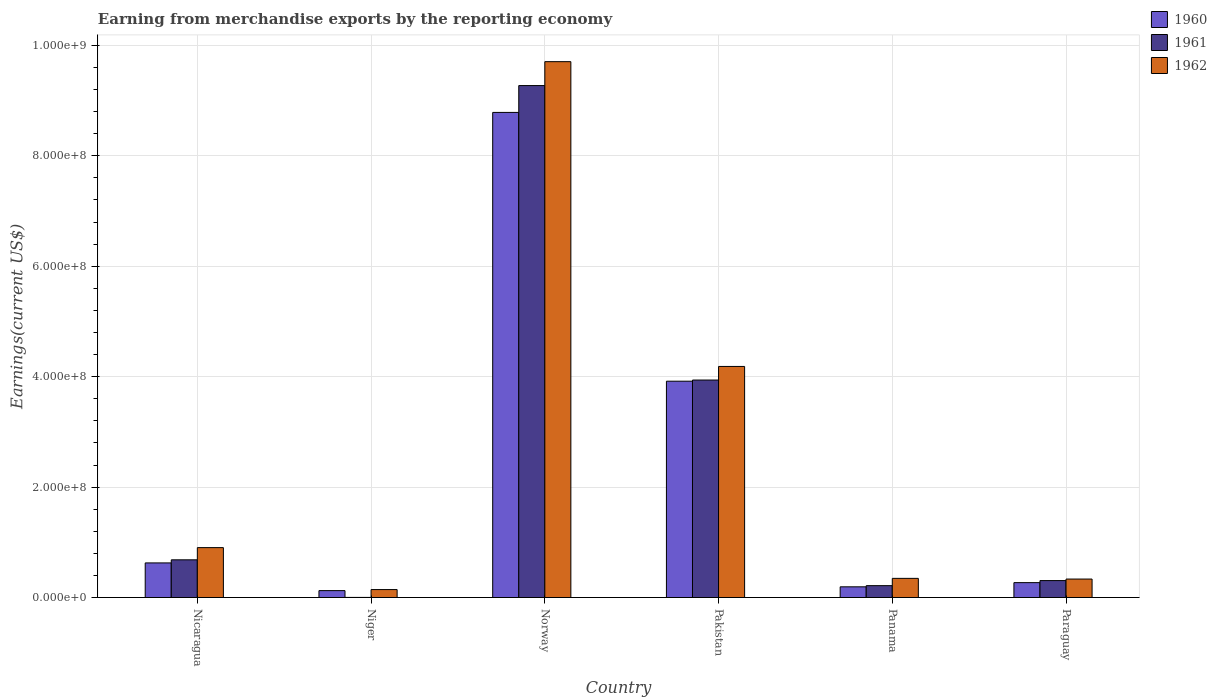How many groups of bars are there?
Keep it short and to the point. 6. Are the number of bars per tick equal to the number of legend labels?
Offer a very short reply. Yes. How many bars are there on the 5th tick from the left?
Make the answer very short. 3. How many bars are there on the 6th tick from the right?
Provide a succinct answer. 3. What is the label of the 6th group of bars from the left?
Your response must be concise. Paraguay. In how many cases, is the number of bars for a given country not equal to the number of legend labels?
Your answer should be very brief. 0. What is the amount earned from merchandise exports in 1962 in Norway?
Your answer should be compact. 9.70e+08. Across all countries, what is the maximum amount earned from merchandise exports in 1961?
Ensure brevity in your answer.  9.27e+08. Across all countries, what is the minimum amount earned from merchandise exports in 1960?
Offer a very short reply. 1.25e+07. In which country was the amount earned from merchandise exports in 1960 maximum?
Make the answer very short. Norway. In which country was the amount earned from merchandise exports in 1960 minimum?
Offer a very short reply. Niger. What is the total amount earned from merchandise exports in 1961 in the graph?
Keep it short and to the point. 1.44e+09. What is the difference between the amount earned from merchandise exports in 1960 in Nicaragua and that in Norway?
Make the answer very short. -8.16e+08. What is the difference between the amount earned from merchandise exports in 1961 in Nicaragua and the amount earned from merchandise exports in 1960 in Paraguay?
Your answer should be compact. 4.13e+07. What is the average amount earned from merchandise exports in 1961 per country?
Ensure brevity in your answer.  2.40e+08. What is the difference between the amount earned from merchandise exports of/in 1962 and amount earned from merchandise exports of/in 1961 in Norway?
Ensure brevity in your answer.  4.33e+07. In how many countries, is the amount earned from merchandise exports in 1960 greater than 880000000 US$?
Provide a short and direct response. 0. What is the ratio of the amount earned from merchandise exports in 1960 in Nicaragua to that in Niger?
Offer a very short reply. 5.02. Is the amount earned from merchandise exports in 1960 in Pakistan less than that in Panama?
Provide a short and direct response. No. Is the difference between the amount earned from merchandise exports in 1962 in Pakistan and Paraguay greater than the difference between the amount earned from merchandise exports in 1961 in Pakistan and Paraguay?
Your answer should be very brief. Yes. What is the difference between the highest and the second highest amount earned from merchandise exports in 1962?
Ensure brevity in your answer.  8.80e+08. What is the difference between the highest and the lowest amount earned from merchandise exports in 1962?
Your answer should be very brief. 9.56e+08. What does the 1st bar from the right in Niger represents?
Ensure brevity in your answer.  1962. Are all the bars in the graph horizontal?
Offer a very short reply. No. How many countries are there in the graph?
Keep it short and to the point. 6. Are the values on the major ticks of Y-axis written in scientific E-notation?
Your answer should be very brief. Yes. Does the graph contain any zero values?
Make the answer very short. No. Where does the legend appear in the graph?
Your response must be concise. Top right. What is the title of the graph?
Keep it short and to the point. Earning from merchandise exports by the reporting economy. What is the label or title of the X-axis?
Ensure brevity in your answer.  Country. What is the label or title of the Y-axis?
Your response must be concise. Earnings(current US$). What is the Earnings(current US$) of 1960 in Nicaragua?
Your answer should be very brief. 6.27e+07. What is the Earnings(current US$) of 1961 in Nicaragua?
Offer a terse response. 6.83e+07. What is the Earnings(current US$) of 1962 in Nicaragua?
Make the answer very short. 9.04e+07. What is the Earnings(current US$) in 1960 in Niger?
Keep it short and to the point. 1.25e+07. What is the Earnings(current US$) of 1961 in Niger?
Your answer should be very brief. 2.00e+05. What is the Earnings(current US$) of 1962 in Niger?
Offer a very short reply. 1.44e+07. What is the Earnings(current US$) in 1960 in Norway?
Offer a terse response. 8.79e+08. What is the Earnings(current US$) of 1961 in Norway?
Ensure brevity in your answer.  9.27e+08. What is the Earnings(current US$) of 1962 in Norway?
Your answer should be very brief. 9.70e+08. What is the Earnings(current US$) in 1960 in Pakistan?
Provide a short and direct response. 3.92e+08. What is the Earnings(current US$) in 1961 in Pakistan?
Provide a succinct answer. 3.94e+08. What is the Earnings(current US$) in 1962 in Pakistan?
Make the answer very short. 4.18e+08. What is the Earnings(current US$) of 1960 in Panama?
Your answer should be compact. 1.94e+07. What is the Earnings(current US$) in 1961 in Panama?
Ensure brevity in your answer.  2.15e+07. What is the Earnings(current US$) of 1962 in Panama?
Provide a succinct answer. 3.47e+07. What is the Earnings(current US$) in 1960 in Paraguay?
Keep it short and to the point. 2.70e+07. What is the Earnings(current US$) of 1961 in Paraguay?
Offer a terse response. 3.07e+07. What is the Earnings(current US$) in 1962 in Paraguay?
Offer a very short reply. 3.35e+07. Across all countries, what is the maximum Earnings(current US$) in 1960?
Provide a succinct answer. 8.79e+08. Across all countries, what is the maximum Earnings(current US$) in 1961?
Provide a succinct answer. 9.27e+08. Across all countries, what is the maximum Earnings(current US$) in 1962?
Provide a succinct answer. 9.70e+08. Across all countries, what is the minimum Earnings(current US$) of 1960?
Keep it short and to the point. 1.25e+07. Across all countries, what is the minimum Earnings(current US$) in 1961?
Offer a terse response. 2.00e+05. Across all countries, what is the minimum Earnings(current US$) of 1962?
Give a very brief answer. 1.44e+07. What is the total Earnings(current US$) in 1960 in the graph?
Make the answer very short. 1.39e+09. What is the total Earnings(current US$) of 1961 in the graph?
Your answer should be very brief. 1.44e+09. What is the total Earnings(current US$) in 1962 in the graph?
Provide a short and direct response. 1.56e+09. What is the difference between the Earnings(current US$) of 1960 in Nicaragua and that in Niger?
Offer a terse response. 5.02e+07. What is the difference between the Earnings(current US$) of 1961 in Nicaragua and that in Niger?
Offer a very short reply. 6.81e+07. What is the difference between the Earnings(current US$) of 1962 in Nicaragua and that in Niger?
Your response must be concise. 7.60e+07. What is the difference between the Earnings(current US$) in 1960 in Nicaragua and that in Norway?
Keep it short and to the point. -8.16e+08. What is the difference between the Earnings(current US$) in 1961 in Nicaragua and that in Norway?
Offer a terse response. -8.59e+08. What is the difference between the Earnings(current US$) of 1962 in Nicaragua and that in Norway?
Provide a short and direct response. -8.80e+08. What is the difference between the Earnings(current US$) in 1960 in Nicaragua and that in Pakistan?
Ensure brevity in your answer.  -3.29e+08. What is the difference between the Earnings(current US$) in 1961 in Nicaragua and that in Pakistan?
Ensure brevity in your answer.  -3.26e+08. What is the difference between the Earnings(current US$) of 1962 in Nicaragua and that in Pakistan?
Keep it short and to the point. -3.28e+08. What is the difference between the Earnings(current US$) of 1960 in Nicaragua and that in Panama?
Provide a succinct answer. 4.33e+07. What is the difference between the Earnings(current US$) of 1961 in Nicaragua and that in Panama?
Keep it short and to the point. 4.68e+07. What is the difference between the Earnings(current US$) in 1962 in Nicaragua and that in Panama?
Provide a succinct answer. 5.57e+07. What is the difference between the Earnings(current US$) of 1960 in Nicaragua and that in Paraguay?
Make the answer very short. 3.57e+07. What is the difference between the Earnings(current US$) of 1961 in Nicaragua and that in Paraguay?
Your response must be concise. 3.76e+07. What is the difference between the Earnings(current US$) in 1962 in Nicaragua and that in Paraguay?
Your answer should be compact. 5.69e+07. What is the difference between the Earnings(current US$) of 1960 in Niger and that in Norway?
Your answer should be compact. -8.66e+08. What is the difference between the Earnings(current US$) of 1961 in Niger and that in Norway?
Provide a succinct answer. -9.27e+08. What is the difference between the Earnings(current US$) of 1962 in Niger and that in Norway?
Your answer should be very brief. -9.56e+08. What is the difference between the Earnings(current US$) in 1960 in Niger and that in Pakistan?
Provide a succinct answer. -3.79e+08. What is the difference between the Earnings(current US$) in 1961 in Niger and that in Pakistan?
Provide a succinct answer. -3.94e+08. What is the difference between the Earnings(current US$) in 1962 in Niger and that in Pakistan?
Keep it short and to the point. -4.04e+08. What is the difference between the Earnings(current US$) of 1960 in Niger and that in Panama?
Make the answer very short. -6.90e+06. What is the difference between the Earnings(current US$) in 1961 in Niger and that in Panama?
Provide a succinct answer. -2.13e+07. What is the difference between the Earnings(current US$) in 1962 in Niger and that in Panama?
Your response must be concise. -2.03e+07. What is the difference between the Earnings(current US$) in 1960 in Niger and that in Paraguay?
Make the answer very short. -1.45e+07. What is the difference between the Earnings(current US$) of 1961 in Niger and that in Paraguay?
Provide a succinct answer. -3.05e+07. What is the difference between the Earnings(current US$) in 1962 in Niger and that in Paraguay?
Ensure brevity in your answer.  -1.91e+07. What is the difference between the Earnings(current US$) of 1960 in Norway and that in Pakistan?
Provide a succinct answer. 4.87e+08. What is the difference between the Earnings(current US$) of 1961 in Norway and that in Pakistan?
Your answer should be very brief. 5.33e+08. What is the difference between the Earnings(current US$) in 1962 in Norway and that in Pakistan?
Provide a short and direct response. 5.52e+08. What is the difference between the Earnings(current US$) in 1960 in Norway and that in Panama?
Your response must be concise. 8.59e+08. What is the difference between the Earnings(current US$) in 1961 in Norway and that in Panama?
Offer a terse response. 9.06e+08. What is the difference between the Earnings(current US$) of 1962 in Norway and that in Panama?
Provide a succinct answer. 9.36e+08. What is the difference between the Earnings(current US$) in 1960 in Norway and that in Paraguay?
Your answer should be compact. 8.52e+08. What is the difference between the Earnings(current US$) of 1961 in Norway and that in Paraguay?
Offer a terse response. 8.97e+08. What is the difference between the Earnings(current US$) of 1962 in Norway and that in Paraguay?
Your response must be concise. 9.37e+08. What is the difference between the Earnings(current US$) of 1960 in Pakistan and that in Panama?
Give a very brief answer. 3.72e+08. What is the difference between the Earnings(current US$) of 1961 in Pakistan and that in Panama?
Offer a terse response. 3.72e+08. What is the difference between the Earnings(current US$) of 1962 in Pakistan and that in Panama?
Provide a short and direct response. 3.84e+08. What is the difference between the Earnings(current US$) in 1960 in Pakistan and that in Paraguay?
Ensure brevity in your answer.  3.65e+08. What is the difference between the Earnings(current US$) of 1961 in Pakistan and that in Paraguay?
Ensure brevity in your answer.  3.63e+08. What is the difference between the Earnings(current US$) in 1962 in Pakistan and that in Paraguay?
Provide a succinct answer. 3.85e+08. What is the difference between the Earnings(current US$) of 1960 in Panama and that in Paraguay?
Provide a succinct answer. -7.58e+06. What is the difference between the Earnings(current US$) of 1961 in Panama and that in Paraguay?
Keep it short and to the point. -9.18e+06. What is the difference between the Earnings(current US$) in 1962 in Panama and that in Paraguay?
Ensure brevity in your answer.  1.23e+06. What is the difference between the Earnings(current US$) in 1960 in Nicaragua and the Earnings(current US$) in 1961 in Niger?
Keep it short and to the point. 6.25e+07. What is the difference between the Earnings(current US$) in 1960 in Nicaragua and the Earnings(current US$) in 1962 in Niger?
Provide a succinct answer. 4.83e+07. What is the difference between the Earnings(current US$) of 1961 in Nicaragua and the Earnings(current US$) of 1962 in Niger?
Provide a succinct answer. 5.39e+07. What is the difference between the Earnings(current US$) of 1960 in Nicaragua and the Earnings(current US$) of 1961 in Norway?
Provide a short and direct response. -8.64e+08. What is the difference between the Earnings(current US$) in 1960 in Nicaragua and the Earnings(current US$) in 1962 in Norway?
Give a very brief answer. -9.08e+08. What is the difference between the Earnings(current US$) of 1961 in Nicaragua and the Earnings(current US$) of 1962 in Norway?
Ensure brevity in your answer.  -9.02e+08. What is the difference between the Earnings(current US$) of 1960 in Nicaragua and the Earnings(current US$) of 1961 in Pakistan?
Offer a very short reply. -3.31e+08. What is the difference between the Earnings(current US$) of 1960 in Nicaragua and the Earnings(current US$) of 1962 in Pakistan?
Keep it short and to the point. -3.56e+08. What is the difference between the Earnings(current US$) in 1961 in Nicaragua and the Earnings(current US$) in 1962 in Pakistan?
Offer a very short reply. -3.50e+08. What is the difference between the Earnings(current US$) of 1960 in Nicaragua and the Earnings(current US$) of 1961 in Panama?
Give a very brief answer. 4.12e+07. What is the difference between the Earnings(current US$) in 1960 in Nicaragua and the Earnings(current US$) in 1962 in Panama?
Your response must be concise. 2.80e+07. What is the difference between the Earnings(current US$) in 1961 in Nicaragua and the Earnings(current US$) in 1962 in Panama?
Ensure brevity in your answer.  3.36e+07. What is the difference between the Earnings(current US$) in 1960 in Nicaragua and the Earnings(current US$) in 1961 in Paraguay?
Your answer should be compact. 3.20e+07. What is the difference between the Earnings(current US$) of 1960 in Nicaragua and the Earnings(current US$) of 1962 in Paraguay?
Ensure brevity in your answer.  2.92e+07. What is the difference between the Earnings(current US$) of 1961 in Nicaragua and the Earnings(current US$) of 1962 in Paraguay?
Your answer should be very brief. 3.48e+07. What is the difference between the Earnings(current US$) of 1960 in Niger and the Earnings(current US$) of 1961 in Norway?
Offer a terse response. -9.15e+08. What is the difference between the Earnings(current US$) in 1960 in Niger and the Earnings(current US$) in 1962 in Norway?
Offer a terse response. -9.58e+08. What is the difference between the Earnings(current US$) in 1961 in Niger and the Earnings(current US$) in 1962 in Norway?
Offer a very short reply. -9.70e+08. What is the difference between the Earnings(current US$) in 1960 in Niger and the Earnings(current US$) in 1961 in Pakistan?
Provide a succinct answer. -3.81e+08. What is the difference between the Earnings(current US$) in 1960 in Niger and the Earnings(current US$) in 1962 in Pakistan?
Give a very brief answer. -4.06e+08. What is the difference between the Earnings(current US$) in 1961 in Niger and the Earnings(current US$) in 1962 in Pakistan?
Ensure brevity in your answer.  -4.18e+08. What is the difference between the Earnings(current US$) of 1960 in Niger and the Earnings(current US$) of 1961 in Panama?
Keep it short and to the point. -9.00e+06. What is the difference between the Earnings(current US$) in 1960 in Niger and the Earnings(current US$) in 1962 in Panama?
Provide a succinct answer. -2.22e+07. What is the difference between the Earnings(current US$) of 1961 in Niger and the Earnings(current US$) of 1962 in Panama?
Ensure brevity in your answer.  -3.45e+07. What is the difference between the Earnings(current US$) in 1960 in Niger and the Earnings(current US$) in 1961 in Paraguay?
Provide a short and direct response. -1.82e+07. What is the difference between the Earnings(current US$) in 1960 in Niger and the Earnings(current US$) in 1962 in Paraguay?
Offer a terse response. -2.10e+07. What is the difference between the Earnings(current US$) of 1961 in Niger and the Earnings(current US$) of 1962 in Paraguay?
Offer a terse response. -3.33e+07. What is the difference between the Earnings(current US$) in 1960 in Norway and the Earnings(current US$) in 1961 in Pakistan?
Offer a terse response. 4.85e+08. What is the difference between the Earnings(current US$) of 1960 in Norway and the Earnings(current US$) of 1962 in Pakistan?
Keep it short and to the point. 4.60e+08. What is the difference between the Earnings(current US$) in 1961 in Norway and the Earnings(current US$) in 1962 in Pakistan?
Your answer should be very brief. 5.09e+08. What is the difference between the Earnings(current US$) of 1960 in Norway and the Earnings(current US$) of 1961 in Panama?
Keep it short and to the point. 8.57e+08. What is the difference between the Earnings(current US$) in 1960 in Norway and the Earnings(current US$) in 1962 in Panama?
Keep it short and to the point. 8.44e+08. What is the difference between the Earnings(current US$) in 1961 in Norway and the Earnings(current US$) in 1962 in Panama?
Offer a terse response. 8.92e+08. What is the difference between the Earnings(current US$) of 1960 in Norway and the Earnings(current US$) of 1961 in Paraguay?
Provide a succinct answer. 8.48e+08. What is the difference between the Earnings(current US$) in 1960 in Norway and the Earnings(current US$) in 1962 in Paraguay?
Your answer should be very brief. 8.45e+08. What is the difference between the Earnings(current US$) of 1961 in Norway and the Earnings(current US$) of 1962 in Paraguay?
Your answer should be compact. 8.94e+08. What is the difference between the Earnings(current US$) of 1960 in Pakistan and the Earnings(current US$) of 1961 in Panama?
Offer a very short reply. 3.70e+08. What is the difference between the Earnings(current US$) of 1960 in Pakistan and the Earnings(current US$) of 1962 in Panama?
Your response must be concise. 3.57e+08. What is the difference between the Earnings(current US$) in 1961 in Pakistan and the Earnings(current US$) in 1962 in Panama?
Give a very brief answer. 3.59e+08. What is the difference between the Earnings(current US$) in 1960 in Pakistan and the Earnings(current US$) in 1961 in Paraguay?
Your answer should be very brief. 3.61e+08. What is the difference between the Earnings(current US$) in 1960 in Pakistan and the Earnings(current US$) in 1962 in Paraguay?
Your response must be concise. 3.58e+08. What is the difference between the Earnings(current US$) in 1961 in Pakistan and the Earnings(current US$) in 1962 in Paraguay?
Offer a terse response. 3.60e+08. What is the difference between the Earnings(current US$) of 1960 in Panama and the Earnings(current US$) of 1961 in Paraguay?
Your answer should be compact. -1.13e+07. What is the difference between the Earnings(current US$) of 1960 in Panama and the Earnings(current US$) of 1962 in Paraguay?
Keep it short and to the point. -1.41e+07. What is the difference between the Earnings(current US$) in 1961 in Panama and the Earnings(current US$) in 1962 in Paraguay?
Offer a terse response. -1.20e+07. What is the average Earnings(current US$) in 1960 per country?
Your response must be concise. 2.32e+08. What is the average Earnings(current US$) of 1961 per country?
Keep it short and to the point. 2.40e+08. What is the average Earnings(current US$) of 1962 per country?
Provide a succinct answer. 2.60e+08. What is the difference between the Earnings(current US$) in 1960 and Earnings(current US$) in 1961 in Nicaragua?
Your response must be concise. -5.60e+06. What is the difference between the Earnings(current US$) of 1960 and Earnings(current US$) of 1962 in Nicaragua?
Ensure brevity in your answer.  -2.77e+07. What is the difference between the Earnings(current US$) in 1961 and Earnings(current US$) in 1962 in Nicaragua?
Give a very brief answer. -2.21e+07. What is the difference between the Earnings(current US$) of 1960 and Earnings(current US$) of 1961 in Niger?
Provide a succinct answer. 1.23e+07. What is the difference between the Earnings(current US$) of 1960 and Earnings(current US$) of 1962 in Niger?
Ensure brevity in your answer.  -1.90e+06. What is the difference between the Earnings(current US$) in 1961 and Earnings(current US$) in 1962 in Niger?
Make the answer very short. -1.42e+07. What is the difference between the Earnings(current US$) of 1960 and Earnings(current US$) of 1961 in Norway?
Keep it short and to the point. -4.86e+07. What is the difference between the Earnings(current US$) in 1960 and Earnings(current US$) in 1962 in Norway?
Offer a terse response. -9.19e+07. What is the difference between the Earnings(current US$) in 1961 and Earnings(current US$) in 1962 in Norway?
Give a very brief answer. -4.33e+07. What is the difference between the Earnings(current US$) in 1960 and Earnings(current US$) in 1961 in Pakistan?
Ensure brevity in your answer.  -2.10e+06. What is the difference between the Earnings(current US$) of 1960 and Earnings(current US$) of 1962 in Pakistan?
Ensure brevity in your answer.  -2.67e+07. What is the difference between the Earnings(current US$) in 1961 and Earnings(current US$) in 1962 in Pakistan?
Offer a very short reply. -2.46e+07. What is the difference between the Earnings(current US$) of 1960 and Earnings(current US$) of 1961 in Panama?
Give a very brief answer. -2.10e+06. What is the difference between the Earnings(current US$) in 1960 and Earnings(current US$) in 1962 in Panama?
Provide a short and direct response. -1.53e+07. What is the difference between the Earnings(current US$) in 1961 and Earnings(current US$) in 1962 in Panama?
Offer a terse response. -1.32e+07. What is the difference between the Earnings(current US$) in 1960 and Earnings(current US$) in 1961 in Paraguay?
Keep it short and to the point. -3.70e+06. What is the difference between the Earnings(current US$) in 1960 and Earnings(current US$) in 1962 in Paraguay?
Provide a succinct answer. -6.49e+06. What is the difference between the Earnings(current US$) in 1961 and Earnings(current US$) in 1962 in Paraguay?
Offer a terse response. -2.79e+06. What is the ratio of the Earnings(current US$) in 1960 in Nicaragua to that in Niger?
Keep it short and to the point. 5.02. What is the ratio of the Earnings(current US$) in 1961 in Nicaragua to that in Niger?
Keep it short and to the point. 341.5. What is the ratio of the Earnings(current US$) in 1962 in Nicaragua to that in Niger?
Your response must be concise. 6.28. What is the ratio of the Earnings(current US$) in 1960 in Nicaragua to that in Norway?
Your answer should be very brief. 0.07. What is the ratio of the Earnings(current US$) of 1961 in Nicaragua to that in Norway?
Give a very brief answer. 0.07. What is the ratio of the Earnings(current US$) in 1962 in Nicaragua to that in Norway?
Offer a very short reply. 0.09. What is the ratio of the Earnings(current US$) in 1960 in Nicaragua to that in Pakistan?
Give a very brief answer. 0.16. What is the ratio of the Earnings(current US$) of 1961 in Nicaragua to that in Pakistan?
Your answer should be compact. 0.17. What is the ratio of the Earnings(current US$) of 1962 in Nicaragua to that in Pakistan?
Provide a short and direct response. 0.22. What is the ratio of the Earnings(current US$) in 1960 in Nicaragua to that in Panama?
Your answer should be very brief. 3.23. What is the ratio of the Earnings(current US$) of 1961 in Nicaragua to that in Panama?
Keep it short and to the point. 3.18. What is the ratio of the Earnings(current US$) in 1962 in Nicaragua to that in Panama?
Give a very brief answer. 2.61. What is the ratio of the Earnings(current US$) in 1960 in Nicaragua to that in Paraguay?
Provide a short and direct response. 2.32. What is the ratio of the Earnings(current US$) of 1961 in Nicaragua to that in Paraguay?
Offer a terse response. 2.23. What is the ratio of the Earnings(current US$) of 1962 in Nicaragua to that in Paraguay?
Give a very brief answer. 2.7. What is the ratio of the Earnings(current US$) in 1960 in Niger to that in Norway?
Offer a very short reply. 0.01. What is the ratio of the Earnings(current US$) in 1962 in Niger to that in Norway?
Give a very brief answer. 0.01. What is the ratio of the Earnings(current US$) of 1960 in Niger to that in Pakistan?
Provide a short and direct response. 0.03. What is the ratio of the Earnings(current US$) of 1962 in Niger to that in Pakistan?
Give a very brief answer. 0.03. What is the ratio of the Earnings(current US$) of 1960 in Niger to that in Panama?
Your answer should be compact. 0.64. What is the ratio of the Earnings(current US$) of 1961 in Niger to that in Panama?
Ensure brevity in your answer.  0.01. What is the ratio of the Earnings(current US$) in 1962 in Niger to that in Panama?
Give a very brief answer. 0.41. What is the ratio of the Earnings(current US$) in 1960 in Niger to that in Paraguay?
Your response must be concise. 0.46. What is the ratio of the Earnings(current US$) of 1961 in Niger to that in Paraguay?
Offer a terse response. 0.01. What is the ratio of the Earnings(current US$) of 1962 in Niger to that in Paraguay?
Give a very brief answer. 0.43. What is the ratio of the Earnings(current US$) in 1960 in Norway to that in Pakistan?
Offer a very short reply. 2.24. What is the ratio of the Earnings(current US$) in 1961 in Norway to that in Pakistan?
Keep it short and to the point. 2.35. What is the ratio of the Earnings(current US$) in 1962 in Norway to that in Pakistan?
Offer a terse response. 2.32. What is the ratio of the Earnings(current US$) of 1960 in Norway to that in Panama?
Your answer should be compact. 45.29. What is the ratio of the Earnings(current US$) of 1961 in Norway to that in Panama?
Your answer should be compact. 43.13. What is the ratio of the Earnings(current US$) of 1962 in Norway to that in Panama?
Offer a terse response. 27.97. What is the ratio of the Earnings(current US$) of 1960 in Norway to that in Paraguay?
Your answer should be compact. 32.57. What is the ratio of the Earnings(current US$) in 1961 in Norway to that in Paraguay?
Ensure brevity in your answer.  30.22. What is the ratio of the Earnings(current US$) of 1962 in Norway to that in Paraguay?
Provide a succinct answer. 29. What is the ratio of the Earnings(current US$) of 1960 in Pakistan to that in Panama?
Provide a short and direct response. 20.2. What is the ratio of the Earnings(current US$) in 1961 in Pakistan to that in Panama?
Provide a short and direct response. 18.32. What is the ratio of the Earnings(current US$) in 1962 in Pakistan to that in Panama?
Offer a terse response. 12.06. What is the ratio of the Earnings(current US$) of 1960 in Pakistan to that in Paraguay?
Ensure brevity in your answer.  14.52. What is the ratio of the Earnings(current US$) of 1961 in Pakistan to that in Paraguay?
Your answer should be compact. 12.84. What is the ratio of the Earnings(current US$) of 1962 in Pakistan to that in Paraguay?
Your response must be concise. 12.5. What is the ratio of the Earnings(current US$) in 1960 in Panama to that in Paraguay?
Keep it short and to the point. 0.72. What is the ratio of the Earnings(current US$) of 1961 in Panama to that in Paraguay?
Give a very brief answer. 0.7. What is the ratio of the Earnings(current US$) of 1962 in Panama to that in Paraguay?
Your response must be concise. 1.04. What is the difference between the highest and the second highest Earnings(current US$) in 1960?
Ensure brevity in your answer.  4.87e+08. What is the difference between the highest and the second highest Earnings(current US$) of 1961?
Make the answer very short. 5.33e+08. What is the difference between the highest and the second highest Earnings(current US$) of 1962?
Offer a terse response. 5.52e+08. What is the difference between the highest and the lowest Earnings(current US$) in 1960?
Offer a very short reply. 8.66e+08. What is the difference between the highest and the lowest Earnings(current US$) in 1961?
Your response must be concise. 9.27e+08. What is the difference between the highest and the lowest Earnings(current US$) in 1962?
Provide a short and direct response. 9.56e+08. 